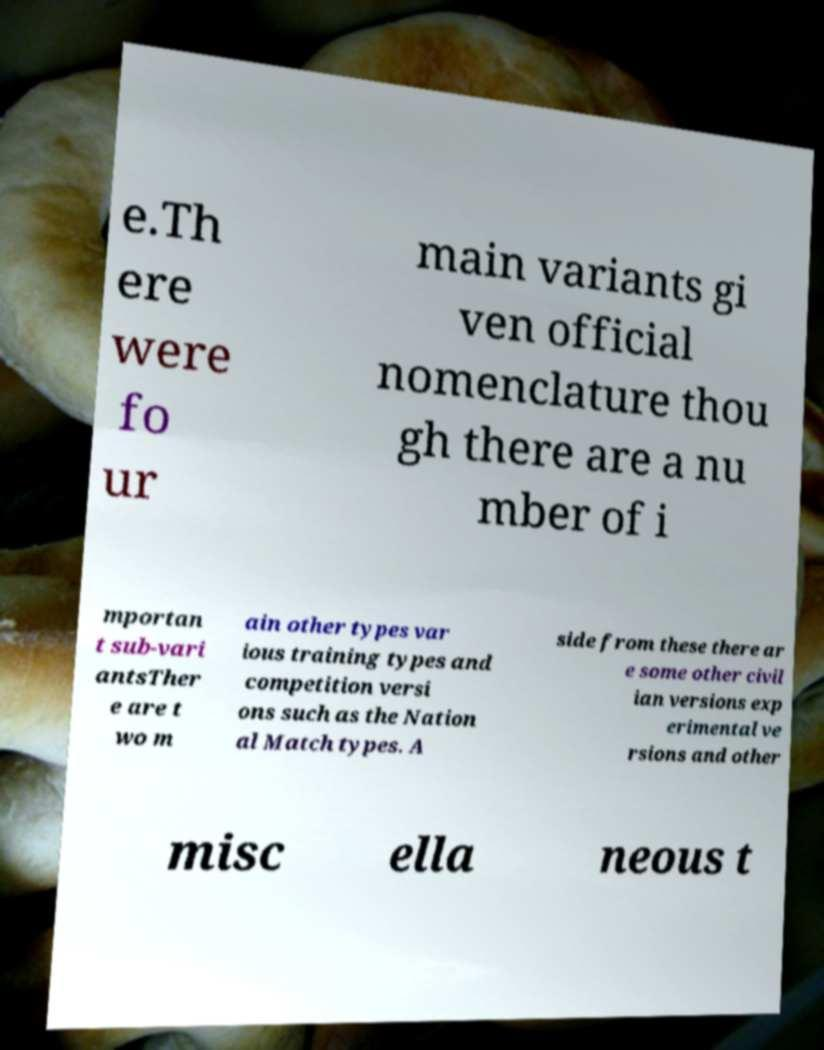There's text embedded in this image that I need extracted. Can you transcribe it verbatim? e.Th ere were fo ur main variants gi ven official nomenclature thou gh there are a nu mber of i mportan t sub-vari antsTher e are t wo m ain other types var ious training types and competition versi ons such as the Nation al Match types. A side from these there ar e some other civil ian versions exp erimental ve rsions and other misc ella neous t 